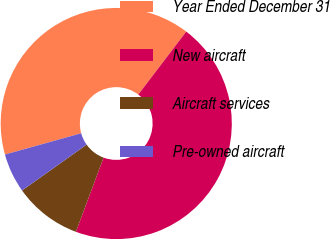<chart> <loc_0><loc_0><loc_500><loc_500><pie_chart><fcel>Year Ended December 31<fcel>New aircraft<fcel>Aircraft services<fcel>Pre-owned aircraft<nl><fcel>39.69%<fcel>45.32%<fcel>9.49%<fcel>5.51%<nl></chart> 